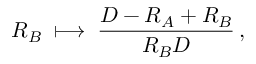Convert formula to latex. <formula><loc_0><loc_0><loc_500><loc_500>R _ { B } \, \longmapsto \, { \frac { D - R _ { A } + R _ { B } } { R _ { B } D } } \, ,</formula> 